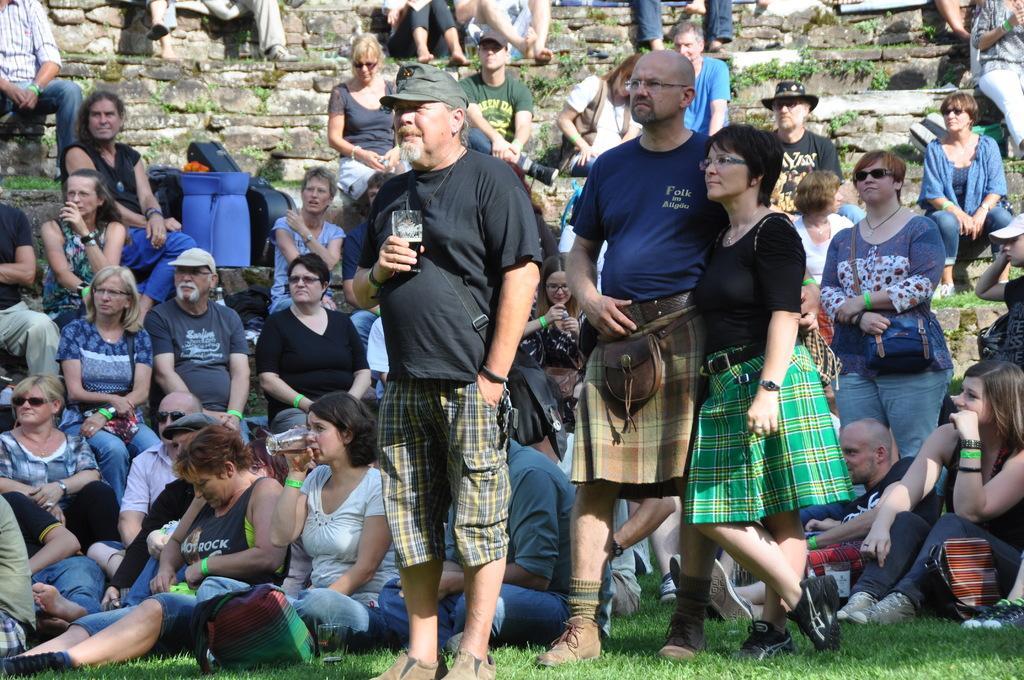In one or two sentences, can you explain what this image depicts? In this image there are a group of people some of them are standing and some of them are sitting. In the background there is a wall and some plants, at the bottom there is grass. 